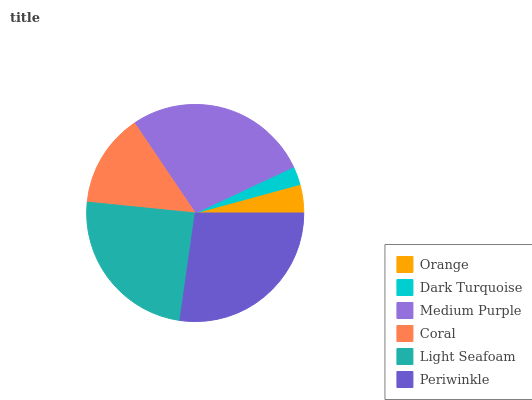Is Dark Turquoise the minimum?
Answer yes or no. Yes. Is Medium Purple the maximum?
Answer yes or no. Yes. Is Medium Purple the minimum?
Answer yes or no. No. Is Dark Turquoise the maximum?
Answer yes or no. No. Is Medium Purple greater than Dark Turquoise?
Answer yes or no. Yes. Is Dark Turquoise less than Medium Purple?
Answer yes or no. Yes. Is Dark Turquoise greater than Medium Purple?
Answer yes or no. No. Is Medium Purple less than Dark Turquoise?
Answer yes or no. No. Is Light Seafoam the high median?
Answer yes or no. Yes. Is Coral the low median?
Answer yes or no. Yes. Is Dark Turquoise the high median?
Answer yes or no. No. Is Light Seafoam the low median?
Answer yes or no. No. 